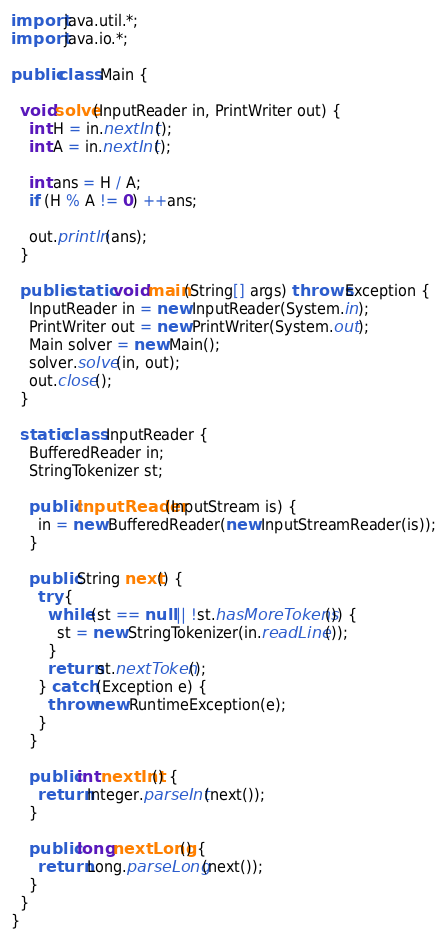<code> <loc_0><loc_0><loc_500><loc_500><_Java_>import java.util.*;
import java.io.*;

public class Main {

  void solve(InputReader in, PrintWriter out) {
    int H = in.nextInt();
    int A = in.nextInt();

    int ans = H / A;
    if (H % A != 0) ++ans;

    out.println(ans);
  }

  public static void main(String[] args) throws Exception {
    InputReader in = new InputReader(System.in);
    PrintWriter out = new PrintWriter(System.out);
    Main solver = new Main();
    solver.solve(in, out);
    out.close();
  }

  static class InputReader {
    BufferedReader in;
    StringTokenizer st;

    public InputReader(InputStream is) {
      in = new BufferedReader(new InputStreamReader(is));
    }

    public String next() {
      try {
        while (st == null || !st.hasMoreTokens()) {
          st = new StringTokenizer(in.readLine());
        }
        return st.nextToken();
      } catch (Exception e) {
        throw new RuntimeException(e);
      }
    }

    public int nextInt() {
      return Integer.parseInt(next());
    }

    public long nextLong() {
      return Long.parseLong(next());
    }
  }
}
</code> 